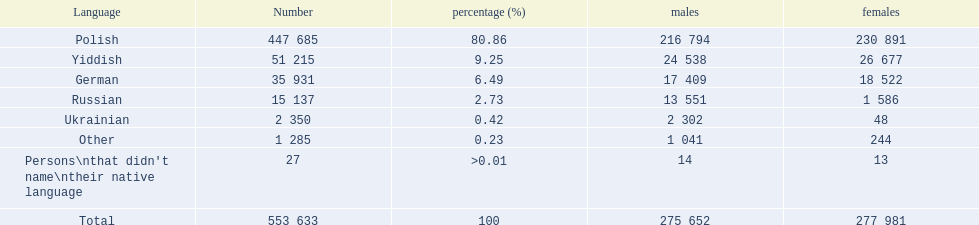How many individuals speak polish? 447 685. What is the count of yiddish speakers? 51 215. What is the combined total of speakers? 553 633. 